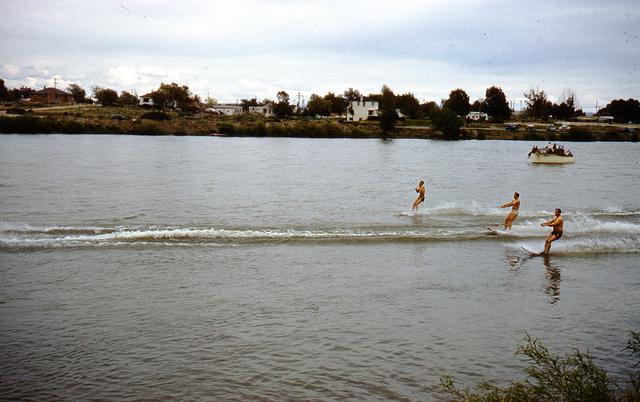Why are the men reaching forward while on skis? Please explain your reasoning. waterskiing. The men are waterskiing. 